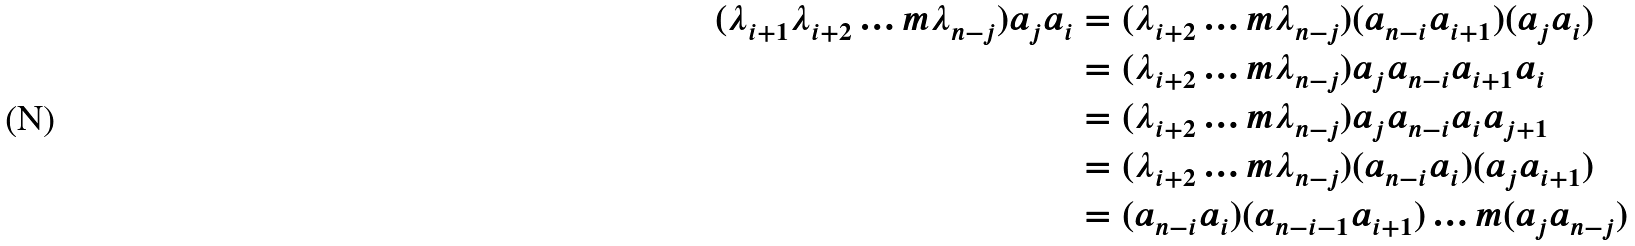<formula> <loc_0><loc_0><loc_500><loc_500>( \lambda _ { i + 1 } \lambda _ { i + 2 } \dots m \lambda _ { n - j } ) a _ { j } a _ { i } & = ( \lambda _ { i + 2 } \dots m \lambda _ { n - j } ) ( a _ { n - i } a _ { i + 1 } ) ( a _ { j } a _ { i } ) \\ & = ( \lambda _ { i + 2 } \dots m \lambda _ { n - j } ) a _ { j } a _ { n - i } a _ { i + 1 } a _ { i } \\ & = ( \lambda _ { i + 2 } \dots m \lambda _ { n - j } ) a _ { j } a _ { n - i } a _ { i } a _ { j + 1 } \\ & = ( \lambda _ { i + 2 } \dots m \lambda _ { n - j } ) ( a _ { n - i } a _ { i } ) ( a _ { j } a _ { i + 1 } ) \\ & = ( a _ { n - i } a _ { i } ) ( a _ { n - i - 1 } a _ { i + 1 } ) \dots m ( a _ { j } a _ { n - j } )</formula> 